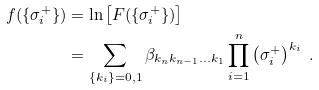<formula> <loc_0><loc_0><loc_500><loc_500>f ( \{ \sigma _ { i } ^ { + } \} ) & = \ln \left [ F ( \{ \sigma _ { i } ^ { + } \} ) \right ] \\ & = \sum _ { \{ k _ { i } \} = { 0 , 1 } } \beta _ { k _ { n } k _ { n - 1 } \dots k _ { 1 } } \prod _ { i = 1 } ^ { n } \left ( \sigma _ { i } ^ { + } \right ) ^ { k _ { i } } \ .</formula> 